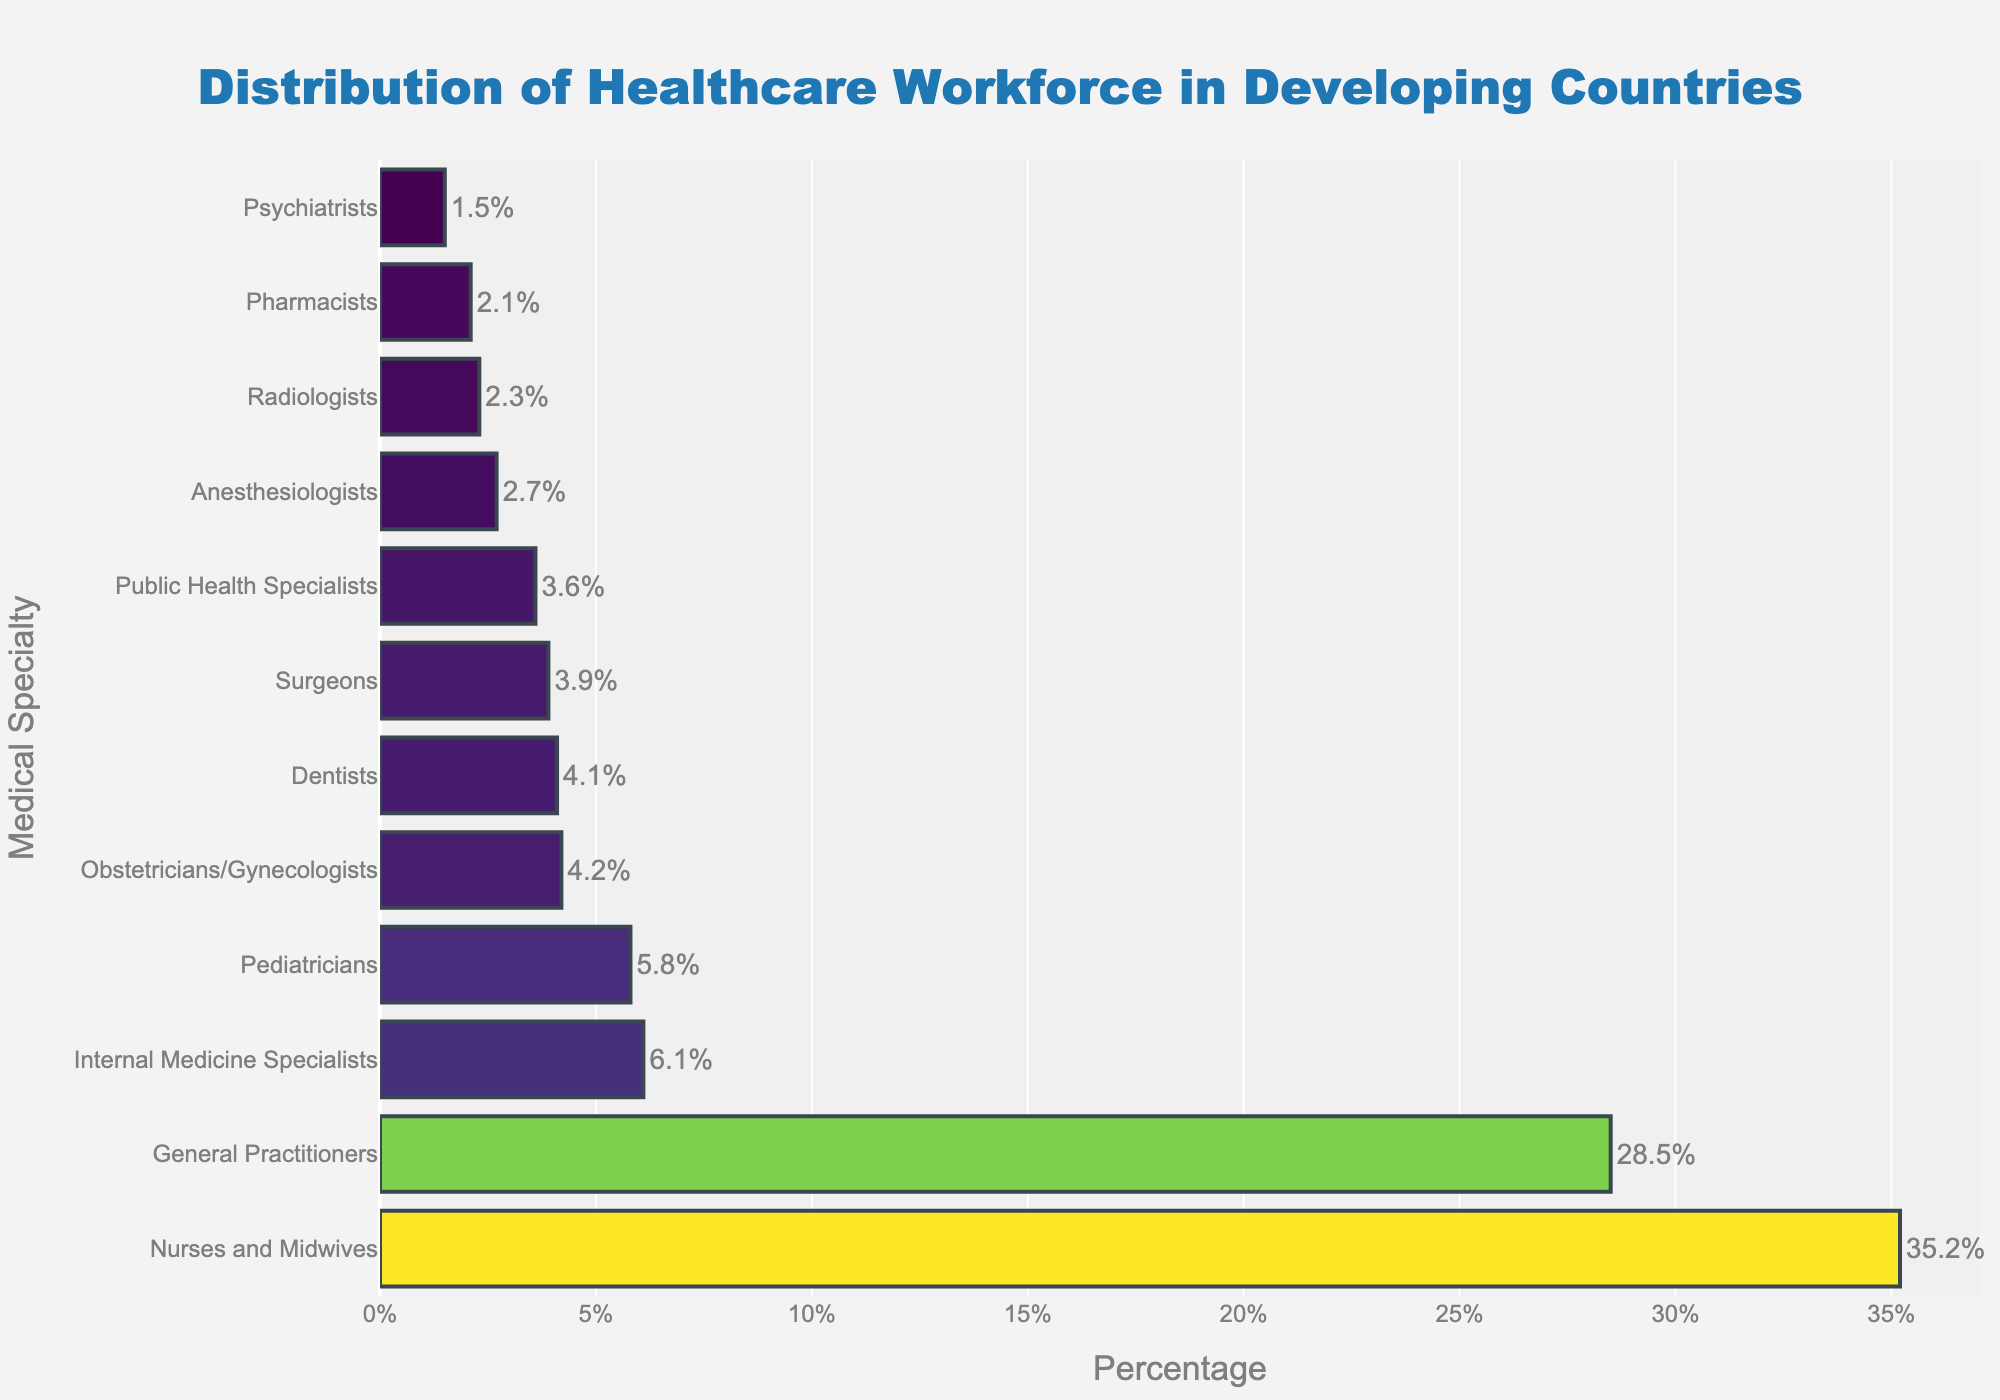what is the specialty with the largest percentage of healthcare workforce? The bar with the longest length represents "Nurses and Midwives," which has the largest percentage.
Answer: Nurses and Midwives Which specialty has a higher percentage of workforce: Surgeons or Obstetricians/Gynecologists? By comparing the lengths of the bars for "Surgeons" and "Obstetricians/Gynecologists," it is clear that "Obstetricians/Gynecologists" has a higher percentage.
Answer: Obstetricians/Gynecologists What is the total percentage of healthcare workforce represented by Pediatricians, Obstetricians/Gynecologists, and Surgeons combined? Summing up the percentages for Pediatricians (5.8%), Obstetricians/Gynecologists (4.2%), and Surgeons (3.9%) gives us 5.8 + 4.2 + 3.9 = 13.9%
Answer: 13.9% What is the difference in percentage between Nurses and Midwives and General Practitioners? Subtract the percentage of General Practitioners (28.5%) from Nurses and Midwives (35.2%): 35.2 - 28.5 = 6.7%
Answer: 6.7% Which specialties have percentages less than 3%? Looking at the bar lengths, "Anesthesiologists," "Psychiatrists," "Radiologists," and "Pharmacists" all have percentages less than 3%.
Answer: Anesthesiologists, Psychiatrists, Radiologists, Pharmacists Which specialty has the smallest percentage of healthcare workforce? By observing the bar with the shortest length, "Psychiatrists" has the smallest percentage of healthcare workforce.
Answer: Psychiatrists What is the average percentage of the workforce for Anesthesiologists, Radiologists, and Pharmacists? Summing the percentages for Anesthesiologists (2.7%), Radiologists (2.3%), and Pharmacists (2.1%) and dividing by 3: (2.7 + 2.3 + 2.1) / 3 = 2.37%
Answer: 2.37% If you combine the percentages of General Practitioners, Internal Medicine Specialists, and Dentists, what is their combined percentage? Adding the percentages of General Practitioners (28.5%), Internal Medicine Specialists (6.1%), and Dentists (4.1%): 28.5 + 6.1 + 4.1 = 38.7%
Answer: 38.7% By what factor is the percentage of Nurses and Midwives greater than the percentage of Pharmacists? Dividing the percentage of Nurses and Midwives (35.2%) by Pharmacists (2.1%) gives us: 35.2 / 2.1 ≈ 16.8 times
Answer: 16.8 times 